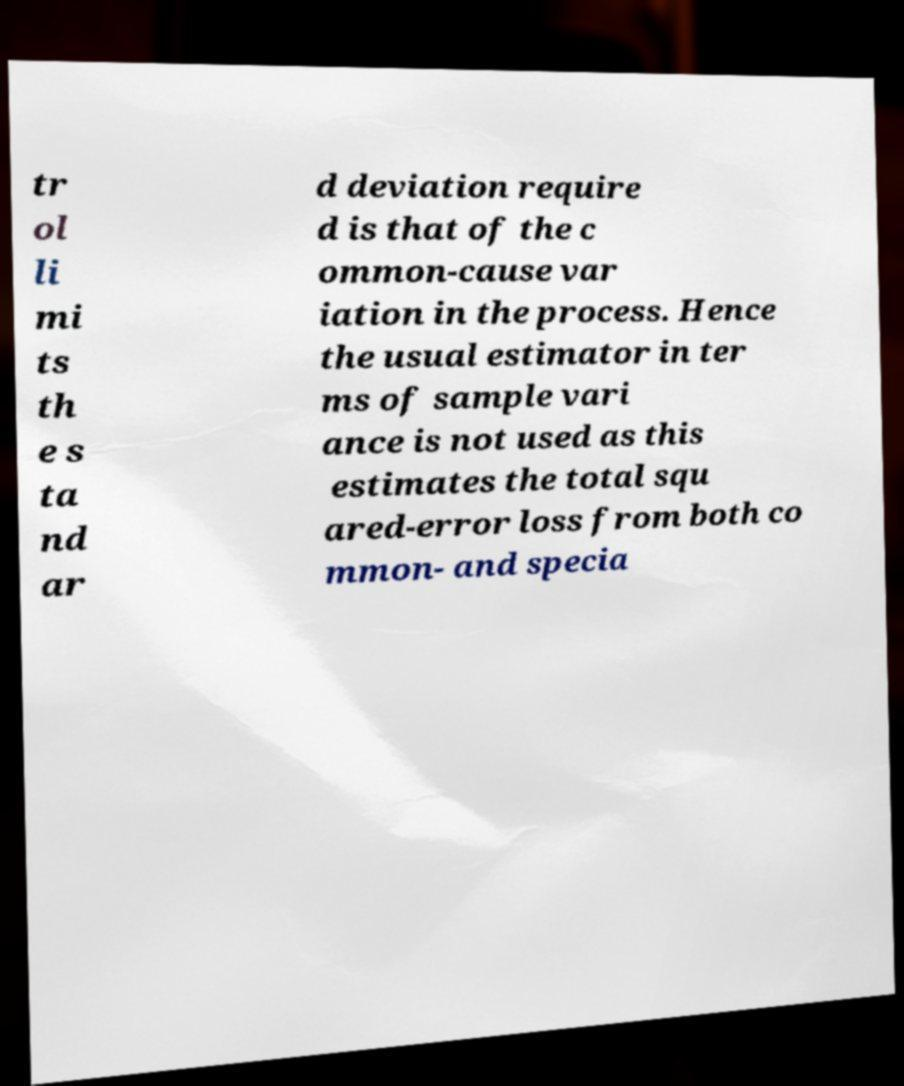Please read and relay the text visible in this image. What does it say? tr ol li mi ts th e s ta nd ar d deviation require d is that of the c ommon-cause var iation in the process. Hence the usual estimator in ter ms of sample vari ance is not used as this estimates the total squ ared-error loss from both co mmon- and specia 